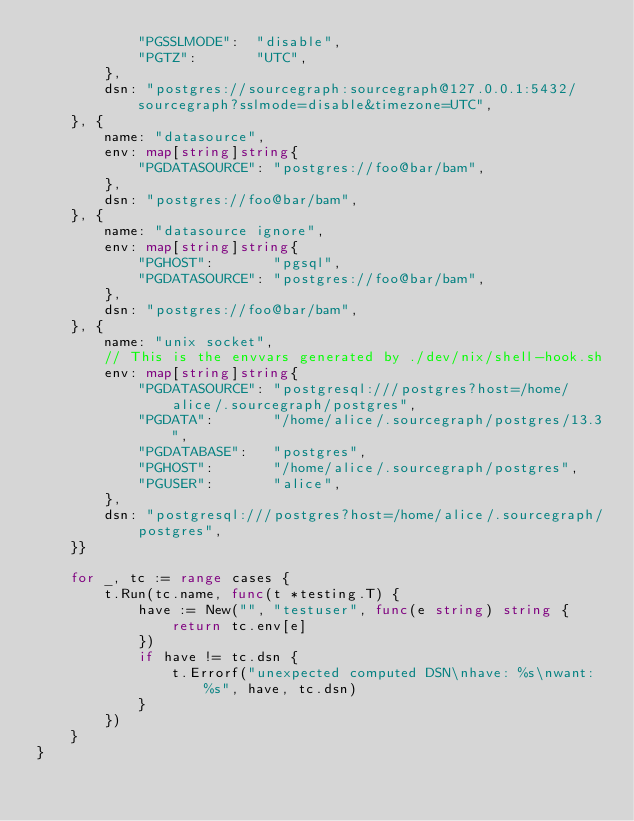<code> <loc_0><loc_0><loc_500><loc_500><_Go_>			"PGSSLMODE":  "disable",
			"PGTZ":       "UTC",
		},
		dsn: "postgres://sourcegraph:sourcegraph@127.0.0.1:5432/sourcegraph?sslmode=disable&timezone=UTC",
	}, {
		name: "datasource",
		env: map[string]string{
			"PGDATASOURCE": "postgres://foo@bar/bam",
		},
		dsn: "postgres://foo@bar/bam",
	}, {
		name: "datasource ignore",
		env: map[string]string{
			"PGHOST":       "pgsql",
			"PGDATASOURCE": "postgres://foo@bar/bam",
		},
		dsn: "postgres://foo@bar/bam",
	}, {
		name: "unix socket",
		// This is the envvars generated by ./dev/nix/shell-hook.sh
		env: map[string]string{
			"PGDATASOURCE": "postgresql:///postgres?host=/home/alice/.sourcegraph/postgres",
			"PGDATA":       "/home/alice/.sourcegraph/postgres/13.3",
			"PGDATABASE":   "postgres",
			"PGHOST":       "/home/alice/.sourcegraph/postgres",
			"PGUSER":       "alice",
		},
		dsn: "postgresql:///postgres?host=/home/alice/.sourcegraph/postgres",
	}}

	for _, tc := range cases {
		t.Run(tc.name, func(t *testing.T) {
			have := New("", "testuser", func(e string) string {
				return tc.env[e]
			})
			if have != tc.dsn {
				t.Errorf("unexpected computed DSN\nhave: %s\nwant: %s", have, tc.dsn)
			}
		})
	}
}
</code> 